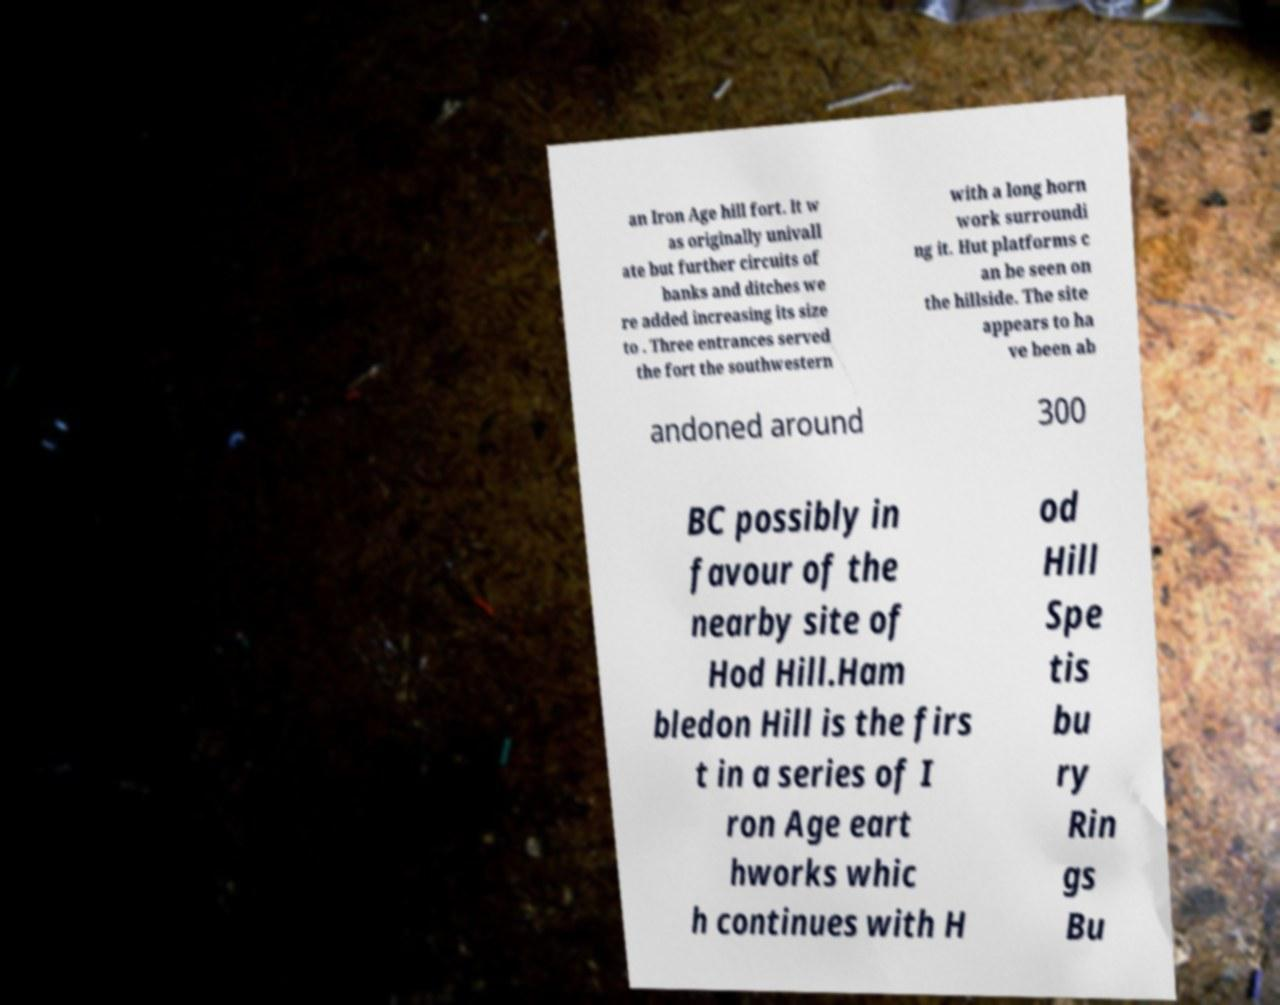Please read and relay the text visible in this image. What does it say? an Iron Age hill fort. It w as originally univall ate but further circuits of banks and ditches we re added increasing its size to . Three entrances served the fort the southwestern with a long horn work surroundi ng it. Hut platforms c an be seen on the hillside. The site appears to ha ve been ab andoned around 300 BC possibly in favour of the nearby site of Hod Hill.Ham bledon Hill is the firs t in a series of I ron Age eart hworks whic h continues with H od Hill Spe tis bu ry Rin gs Bu 